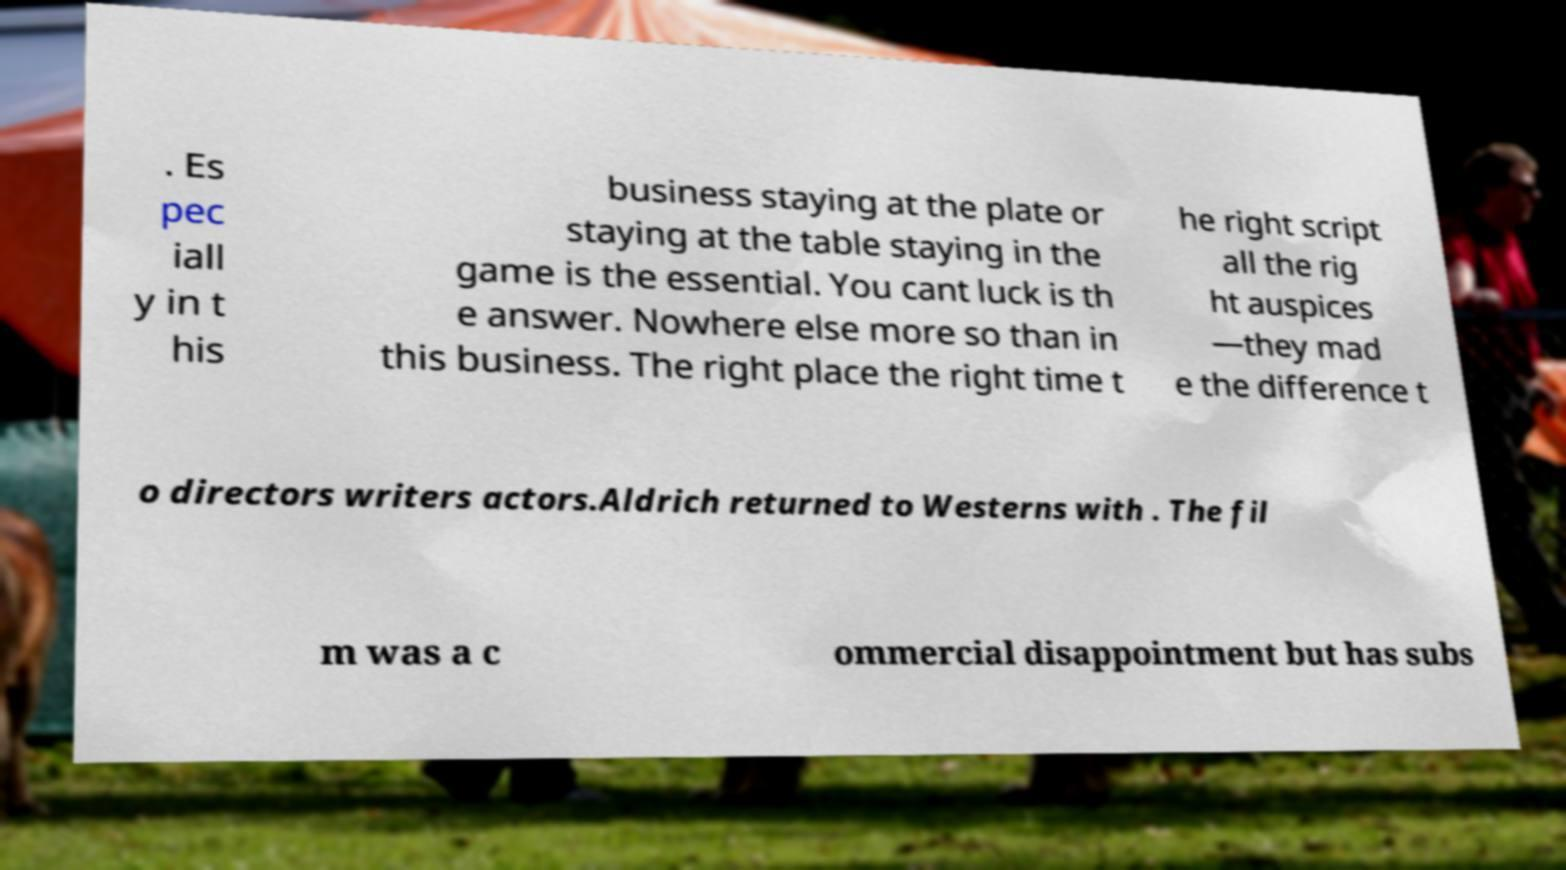Please identify and transcribe the text found in this image. . Es pec iall y in t his business staying at the plate or staying at the table staying in the game is the essential. You cant luck is th e answer. Nowhere else more so than in this business. The right place the right time t he right script all the rig ht auspices —they mad e the difference t o directors writers actors.Aldrich returned to Westerns with . The fil m was a c ommercial disappointment but has subs 